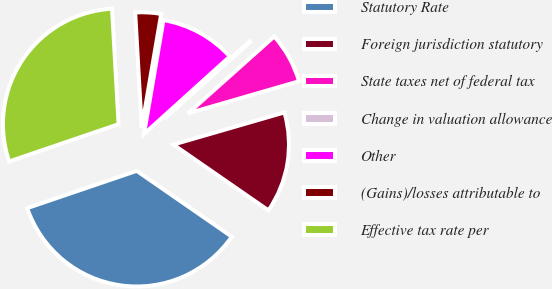Convert chart. <chart><loc_0><loc_0><loc_500><loc_500><pie_chart><fcel>Statutory Rate<fcel>Foreign jurisdiction statutory<fcel>State taxes net of federal tax<fcel>Change in valuation allowance<fcel>Other<fcel>(Gains)/losses attributable to<fcel>Effective tax rate per<nl><fcel>35.14%<fcel>14.12%<fcel>7.11%<fcel>0.1%<fcel>10.61%<fcel>3.6%<fcel>29.32%<nl></chart> 